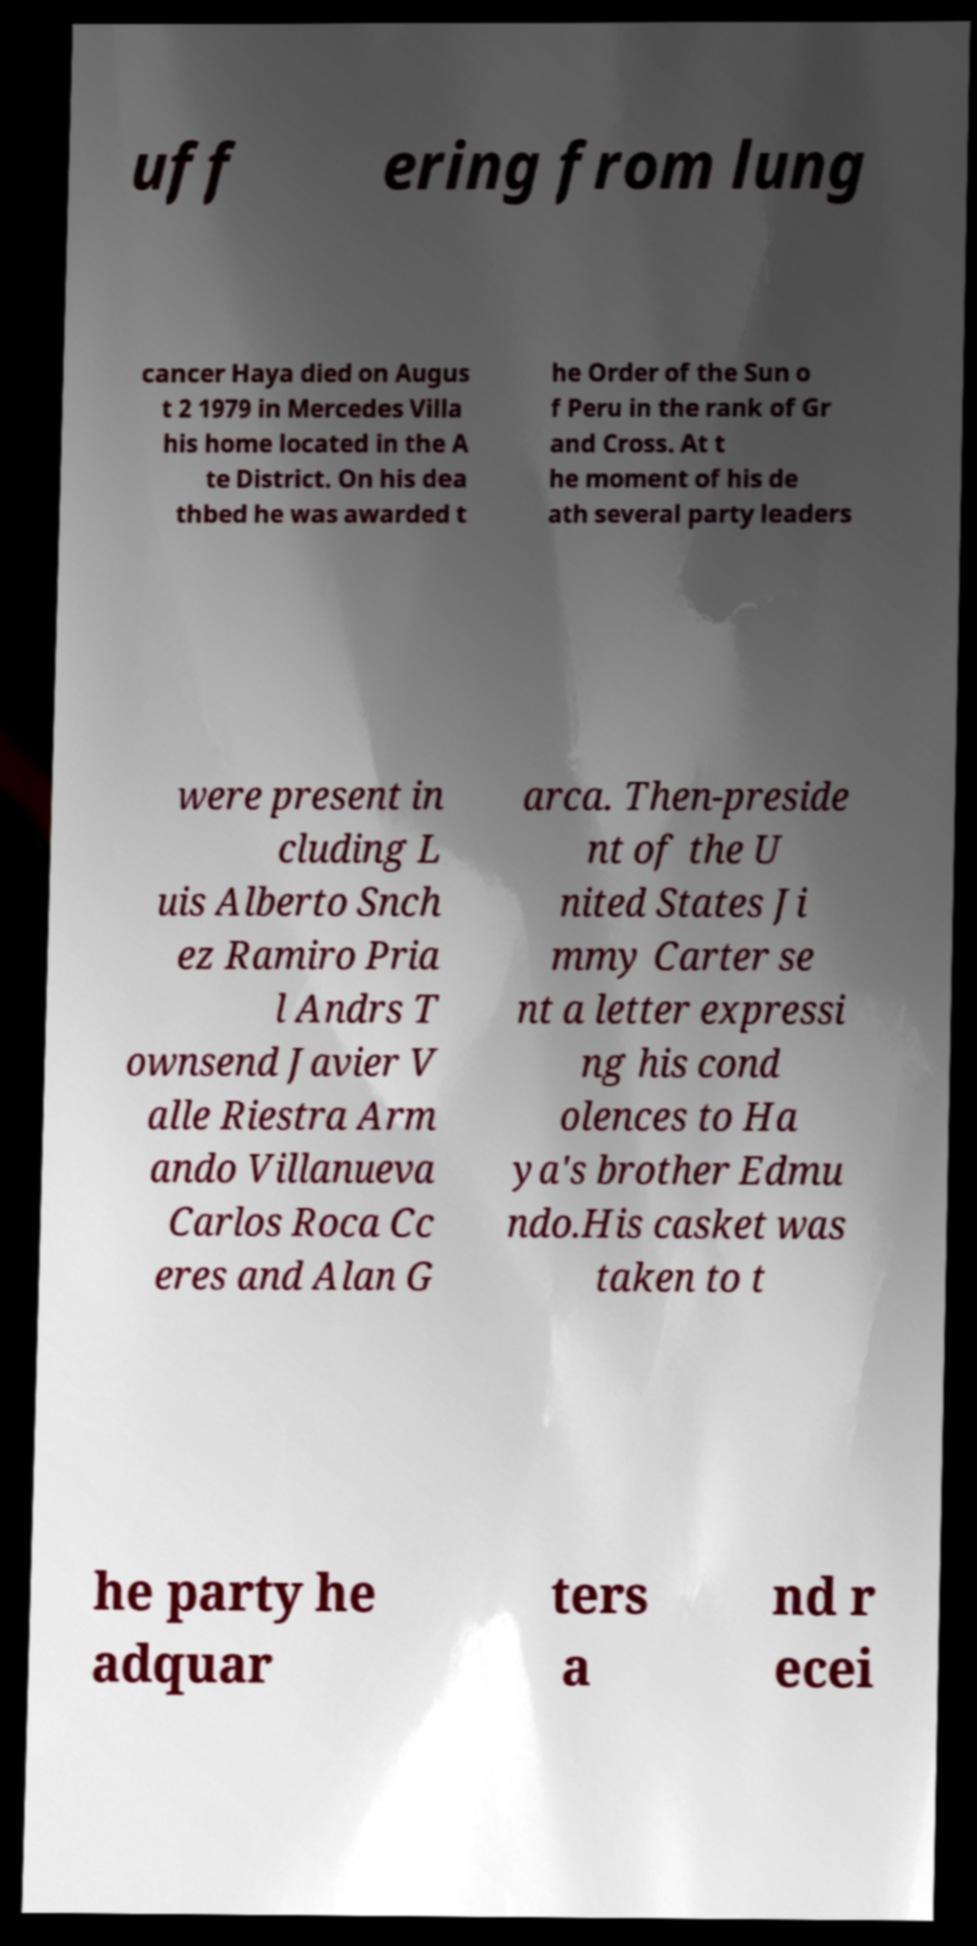What messages or text are displayed in this image? I need them in a readable, typed format. uff ering from lung cancer Haya died on Augus t 2 1979 in Mercedes Villa his home located in the A te District. On his dea thbed he was awarded t he Order of the Sun o f Peru in the rank of Gr and Cross. At t he moment of his de ath several party leaders were present in cluding L uis Alberto Snch ez Ramiro Pria l Andrs T ownsend Javier V alle Riestra Arm ando Villanueva Carlos Roca Cc eres and Alan G arca. Then-preside nt of the U nited States Ji mmy Carter se nt a letter expressi ng his cond olences to Ha ya's brother Edmu ndo.His casket was taken to t he party he adquar ters a nd r ecei 